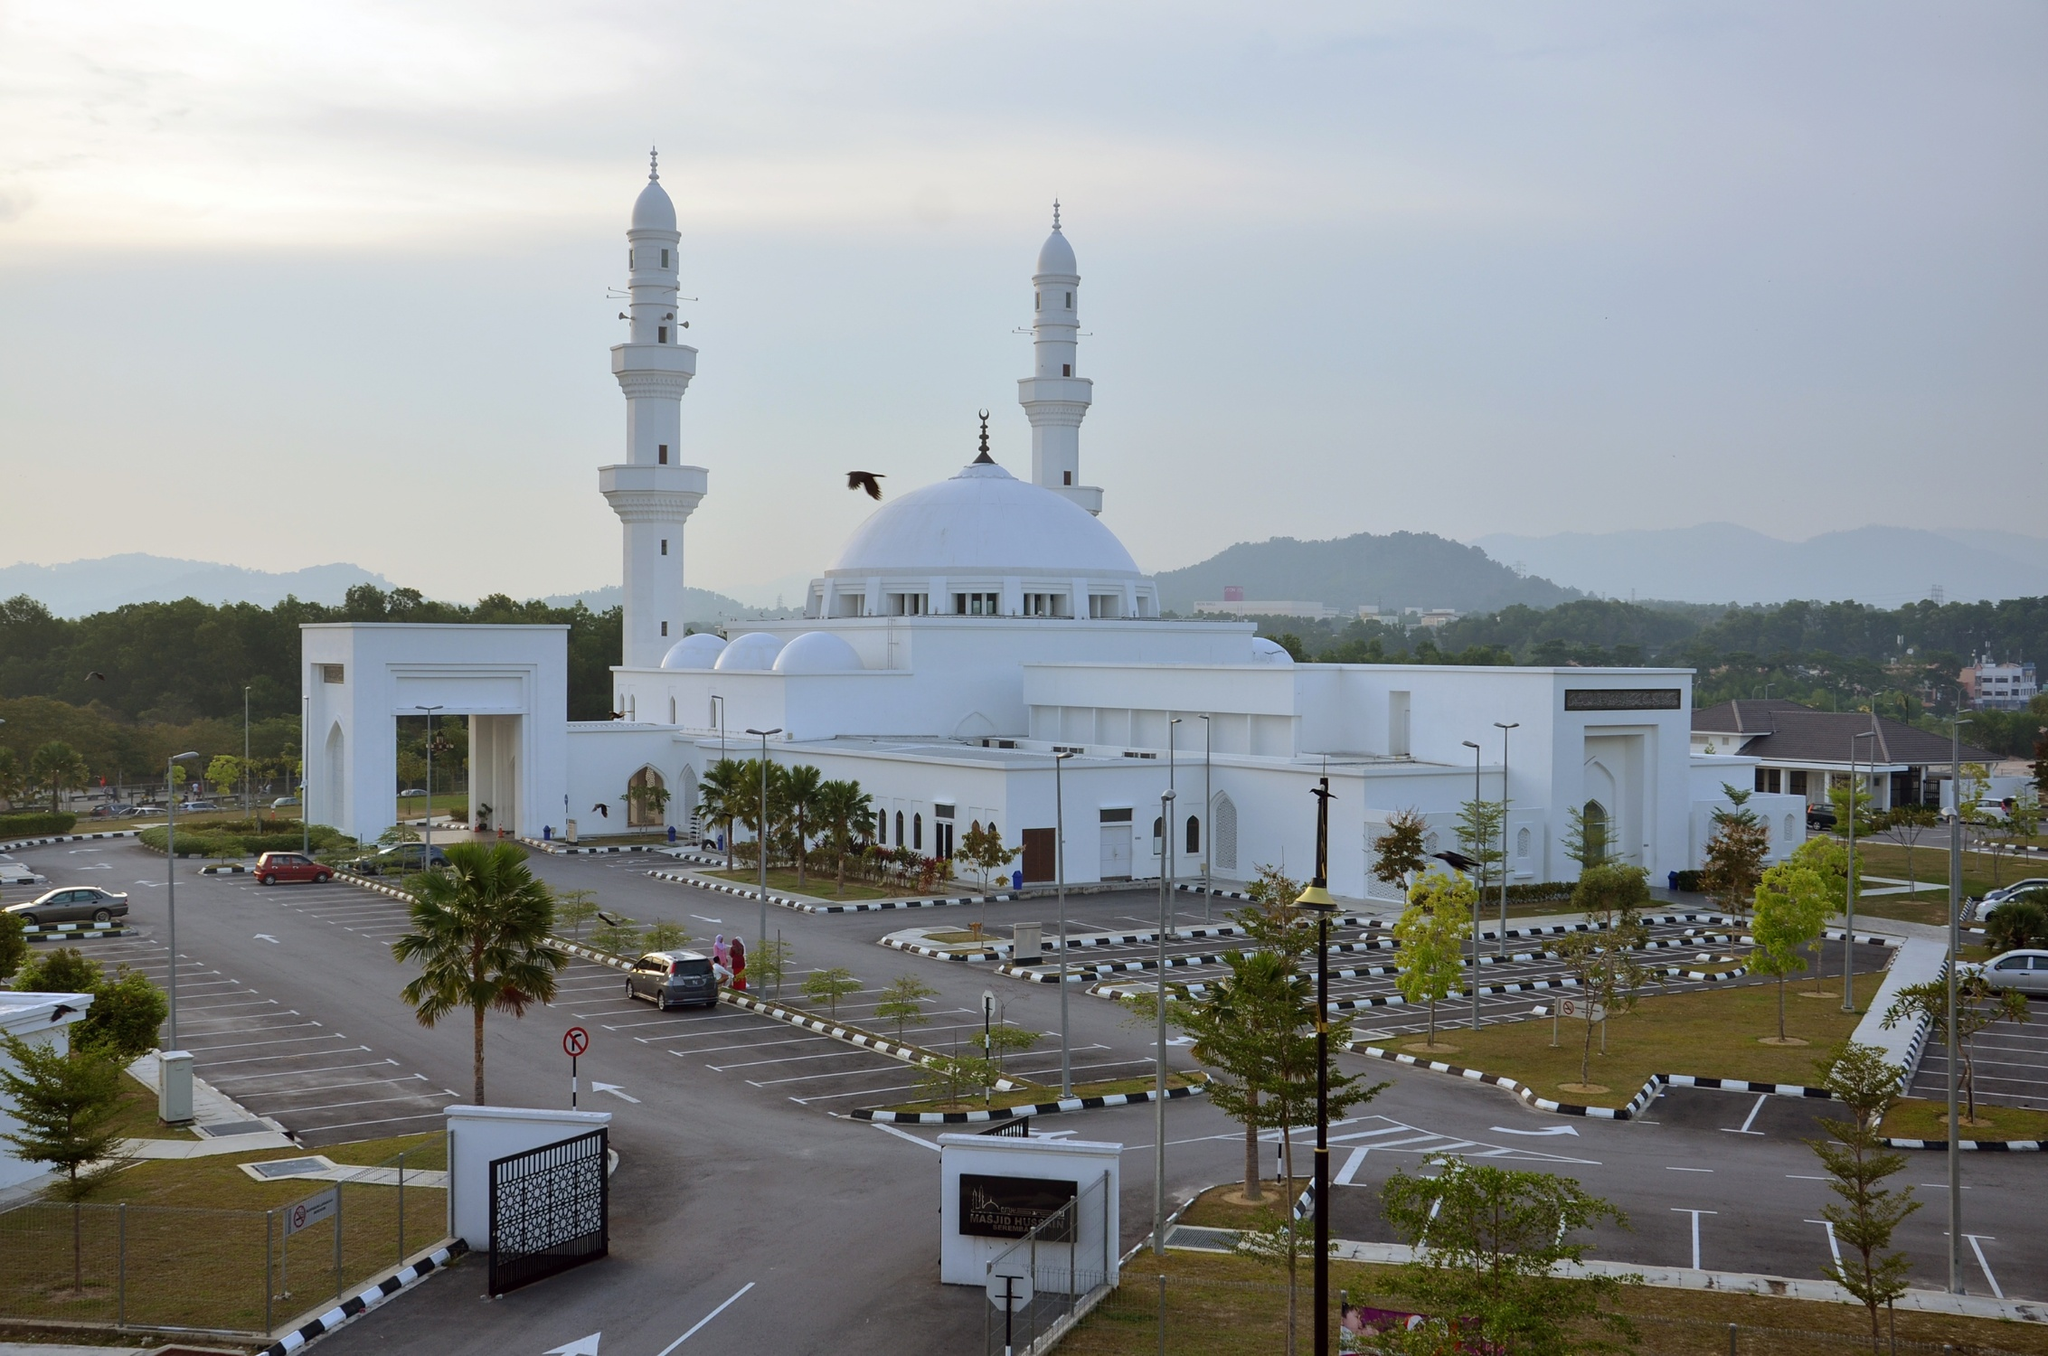Describe the following image. The image beautifully captures the majestic Tengku Ampuan Jemaah Mosque, a significant landmark in Bukit Jelutong, Malaysia. The mosque is resplendent in a clean white hue, standing in stark contrast to the soft, hazy sky. Dominating the scene are its grand central dome and two towering minarets, epitomizing classic Islamic architecture. The photo is taken from a distance, revealing a spacious parking lot punctuated by neat rows of trees and well-maintained landscaping in the foreground. The overall color scheme is subdued, lending the scene a calm and peaceful atmosphere. This mosque, with its architectural splendor, serves as a prominent symbol of faith and community unity. 